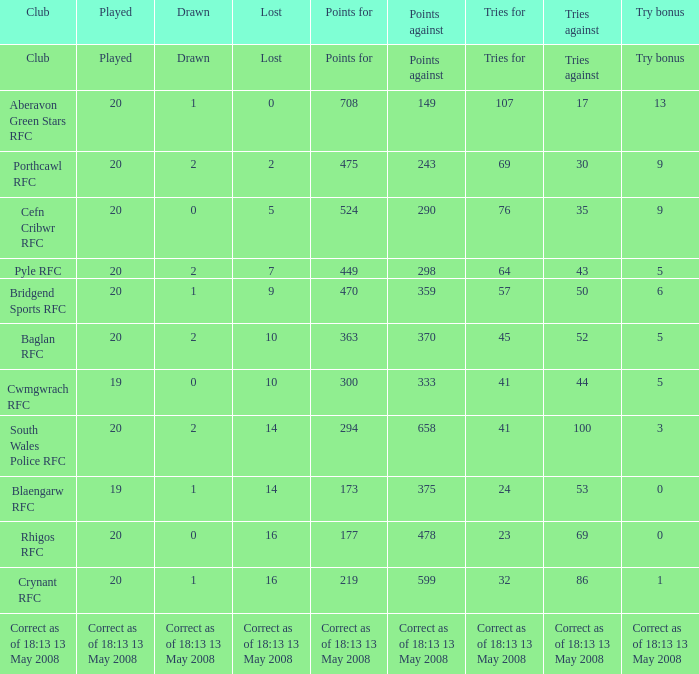What club has a played number of 19, and the lost of 14? Blaengarw RFC. 